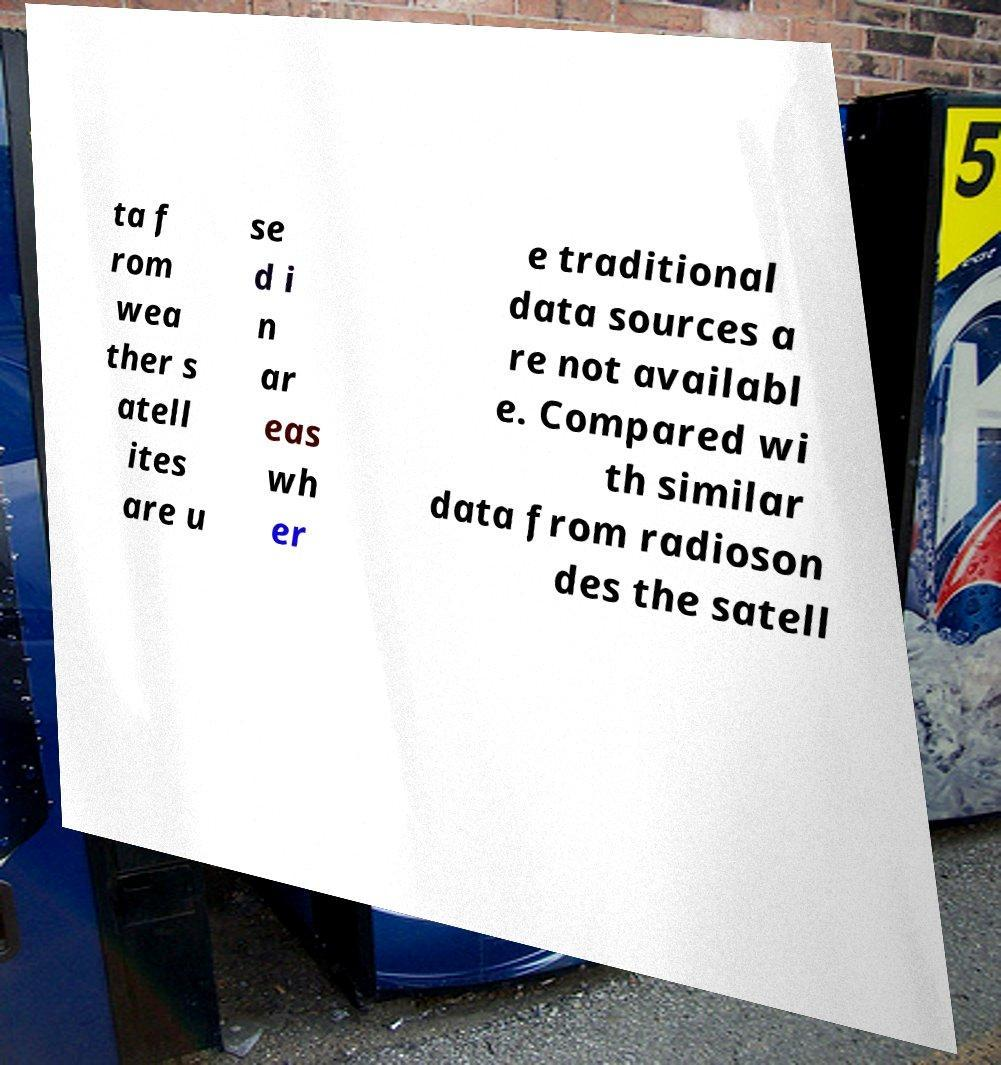Could you extract and type out the text from this image? ta f rom wea ther s atell ites are u se d i n ar eas wh er e traditional data sources a re not availabl e. Compared wi th similar data from radioson des the satell 